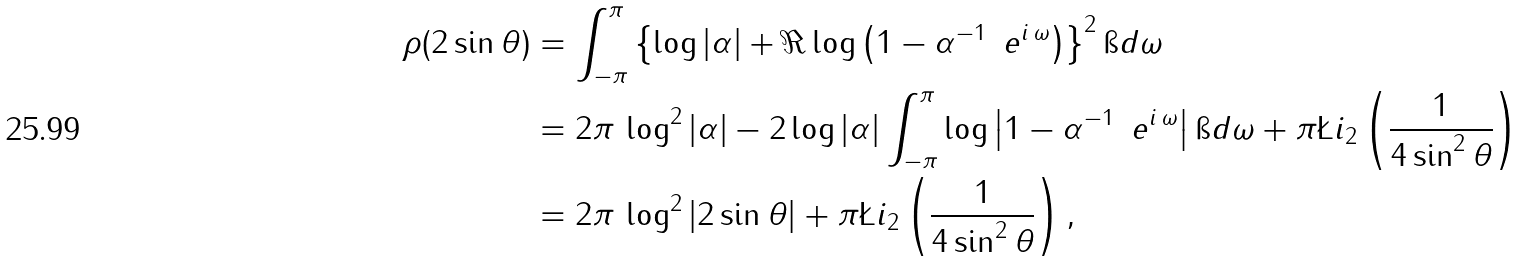Convert formula to latex. <formula><loc_0><loc_0><loc_500><loc_500>\rho ( 2 \sin \theta ) & = \int _ { - \pi } ^ { \pi } \left \{ \log | \alpha | + \Re \log \left ( 1 - \alpha ^ { - 1 } \, \ e ^ { i \, \omega } \right ) \right \} ^ { 2 } \i d \omega \\ & = 2 \pi \, \log ^ { 2 } | \alpha | - 2 \log | \alpha | \int _ { - \pi } ^ { \pi } \log \left | 1 - \alpha ^ { - 1 } \, \ e ^ { i \, \omega } \right | \i d \omega + \pi \L i _ { 2 } \left ( \frac { 1 } { 4 \sin ^ { 2 } \theta } \right ) \\ & = 2 \pi \, \log ^ { 2 } | 2 \sin \theta | + \pi \L i _ { 2 } \left ( \frac { 1 } { 4 \sin ^ { 2 } \theta } \right ) ,</formula> 